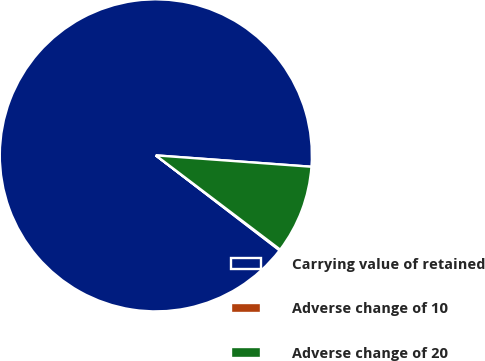Convert chart to OTSL. <chart><loc_0><loc_0><loc_500><loc_500><pie_chart><fcel>Carrying value of retained<fcel>Adverse change of 10<fcel>Adverse change of 20<nl><fcel>90.75%<fcel>0.09%<fcel>9.16%<nl></chart> 